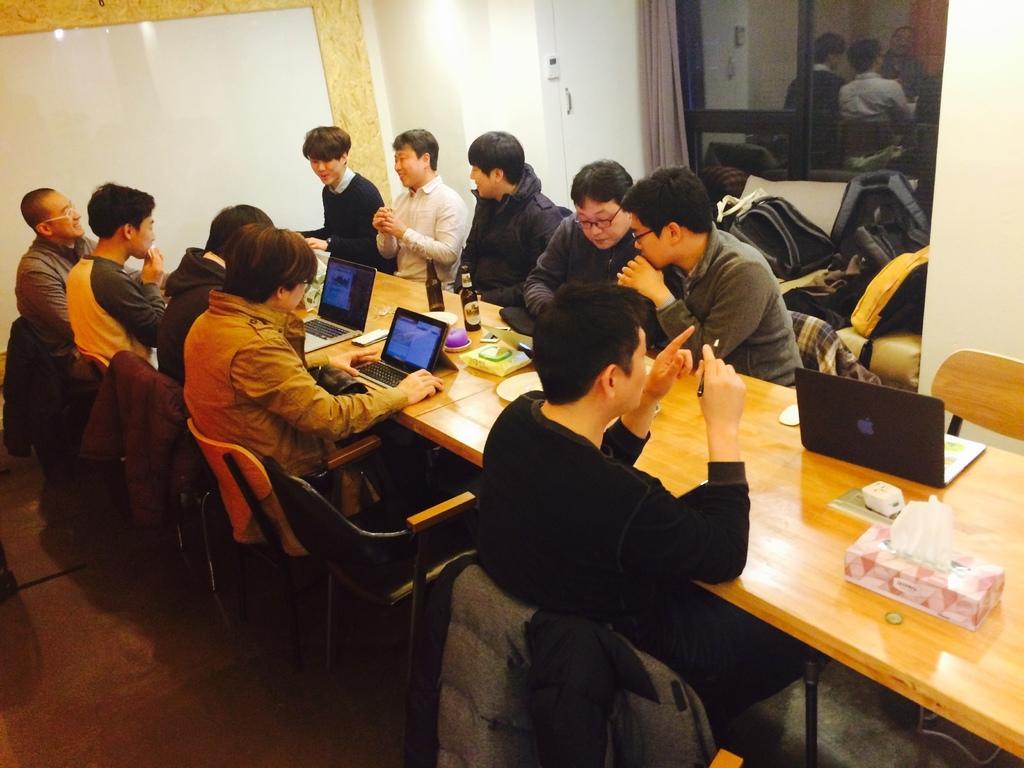Can you describe this image briefly? In this picture we can see group of people sitting on chairs in front of a table, these two people are looking at laptop on the right side of the image we can see a glass door, in background we can see a wall, on the right side of the table we can see tissue papers, the man on the right side is pointing his fingers towards something these two persons talking with each other. 